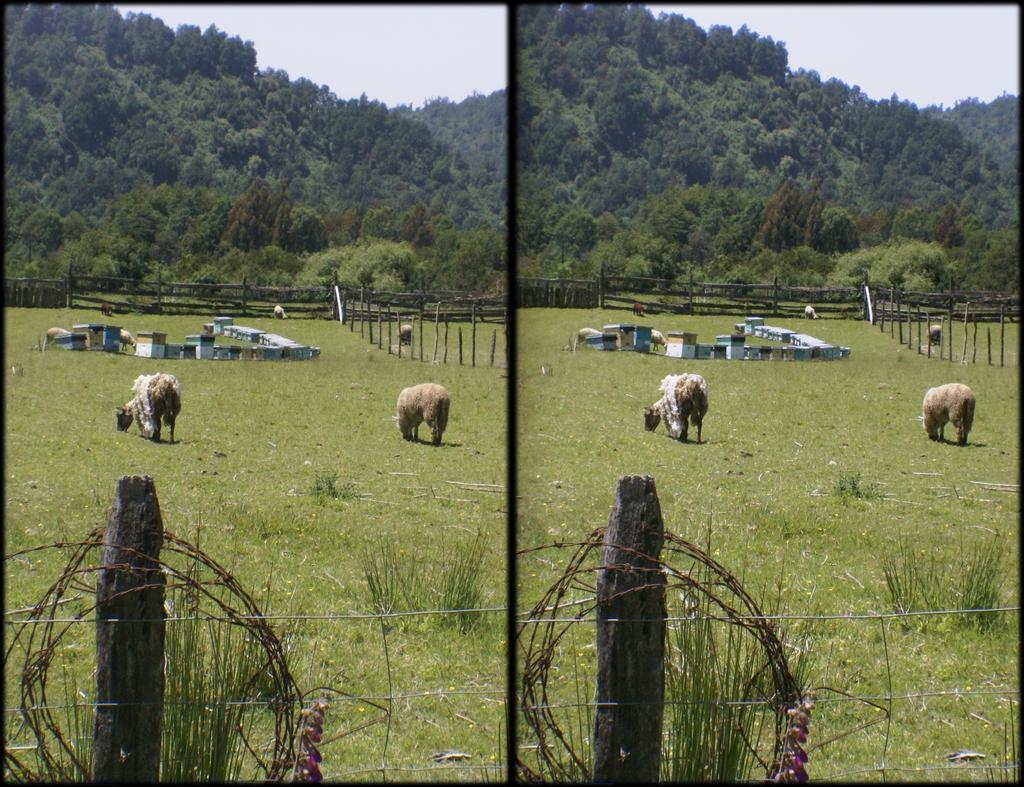What type of structure can be seen in the image? There is a pole with an iron fence in the image. What are the sheep in the image doing? The sheep are present in the image, and they are eating grass. Are there any seating options in the image? Yes, there are benches in the image. What is the wooden fence used for in the image? The wooden fence is present in the image, but its purpose is not specified. What natural features can be seen in the image? Mountains and trees are visible in the image. What type of coach can be seen in the image? There is no coach present in the image. Is the steam visible in the image? There is no steam visible in the image. 